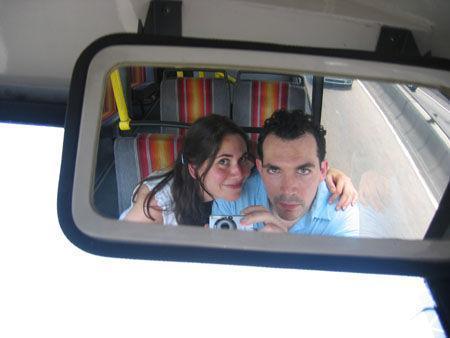They are taking this photo in what?
Answer the question by selecting the correct answer among the 4 following choices and explain your choice with a short sentence. The answer should be formatted with the following format: `Answer: choice
Rationale: rationale.`
Options: Bus, car, train, airplane. Answer: bus.
Rationale: The people are taking a photo while sitting in bus seats. 